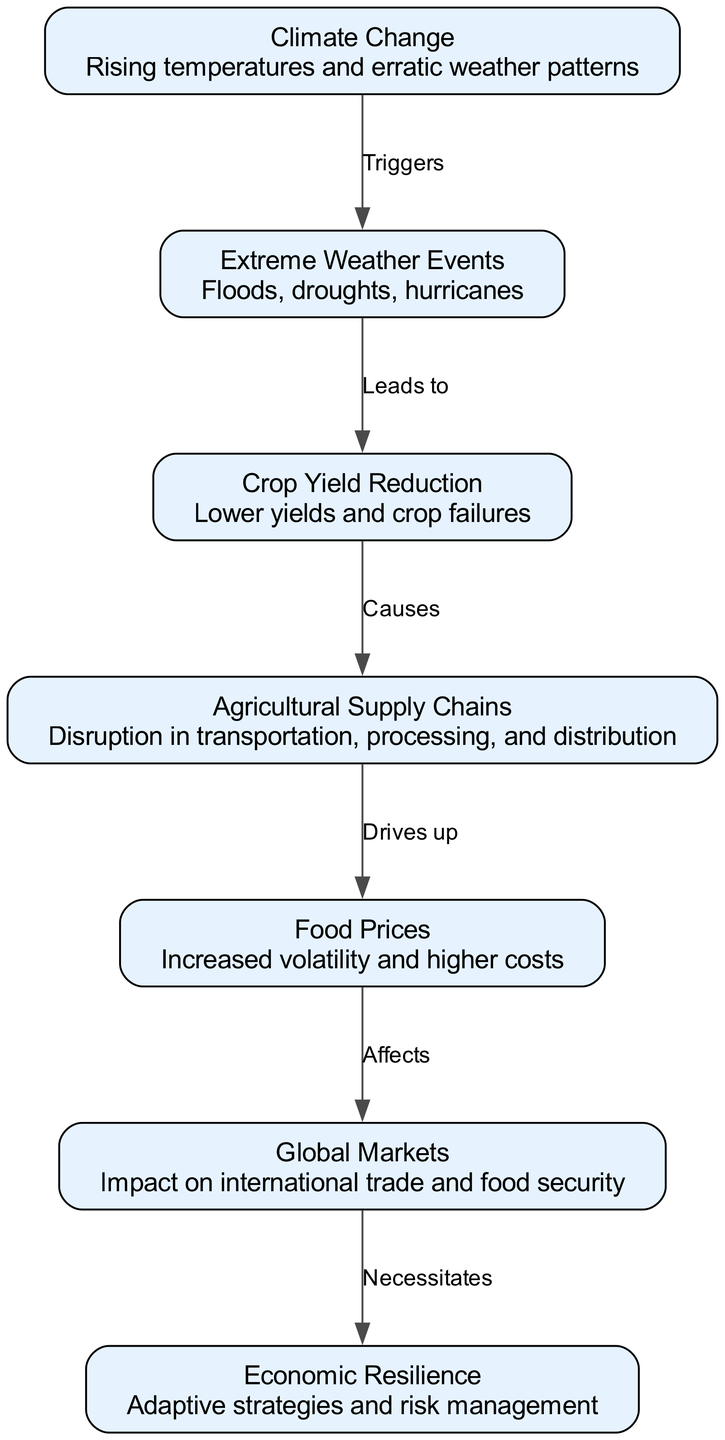What are the main triggers identified in the diagram? The diagram shows that "Climate Change" is the primary trigger for "Extreme Weather Events." This relationship is depicted with a directed edge labeled "Triggers."
Answer: Climate Change How many nodes are present in the diagram? The diagram includes 7 unique nodes, representing different concepts related to the economic impact of climate change on agricultural supply chains.
Answer: 7 What leads to crop yield reduction? From the diagram, "Extreme Weather Events" lead to "Crop Yield Reduction," indicating a direct impact of adverse weather on agricultural output.
Answer: Extreme Weather Events What is the relationship between agricultural supply chains and food prices? The diagram indicates that "Agricultural Supply Chains" causes an increase in "Food Prices," portrayed through a directed edge labeled "Drives up."
Answer: Drives up Which node necessitates economic resilience? The "Global Markets" node necessitates "Economic Resilience," signifying that international trade dynamics and food security issues demand adaptive strategies for managing risks.
Answer: Economic Resilience Is there a direct relationship from extreme weather events to crop yield reduction? Yes, the diagram illustrates a direct causal relationship where "Extreme Weather Events" lead to "Crop Yield Reduction," indicating that such weather directly impacts agricultural output.
Answer: Yes What impacts global markets according to the diagram? "Food Prices" affects "Global Markets," highlighting that fluctuations in food costs can influence international trade and food security measures.
Answer: Food Prices What does crop yield reduction lead to in the supply chain? "Crop Yield Reduction" causes disruptions in "Agricultural Supply Chains," as indicated by the directed edge labeled "Causes." This signifies that lower yields disrupt the entire supply process.
Answer: Agricultural Supply Chains 